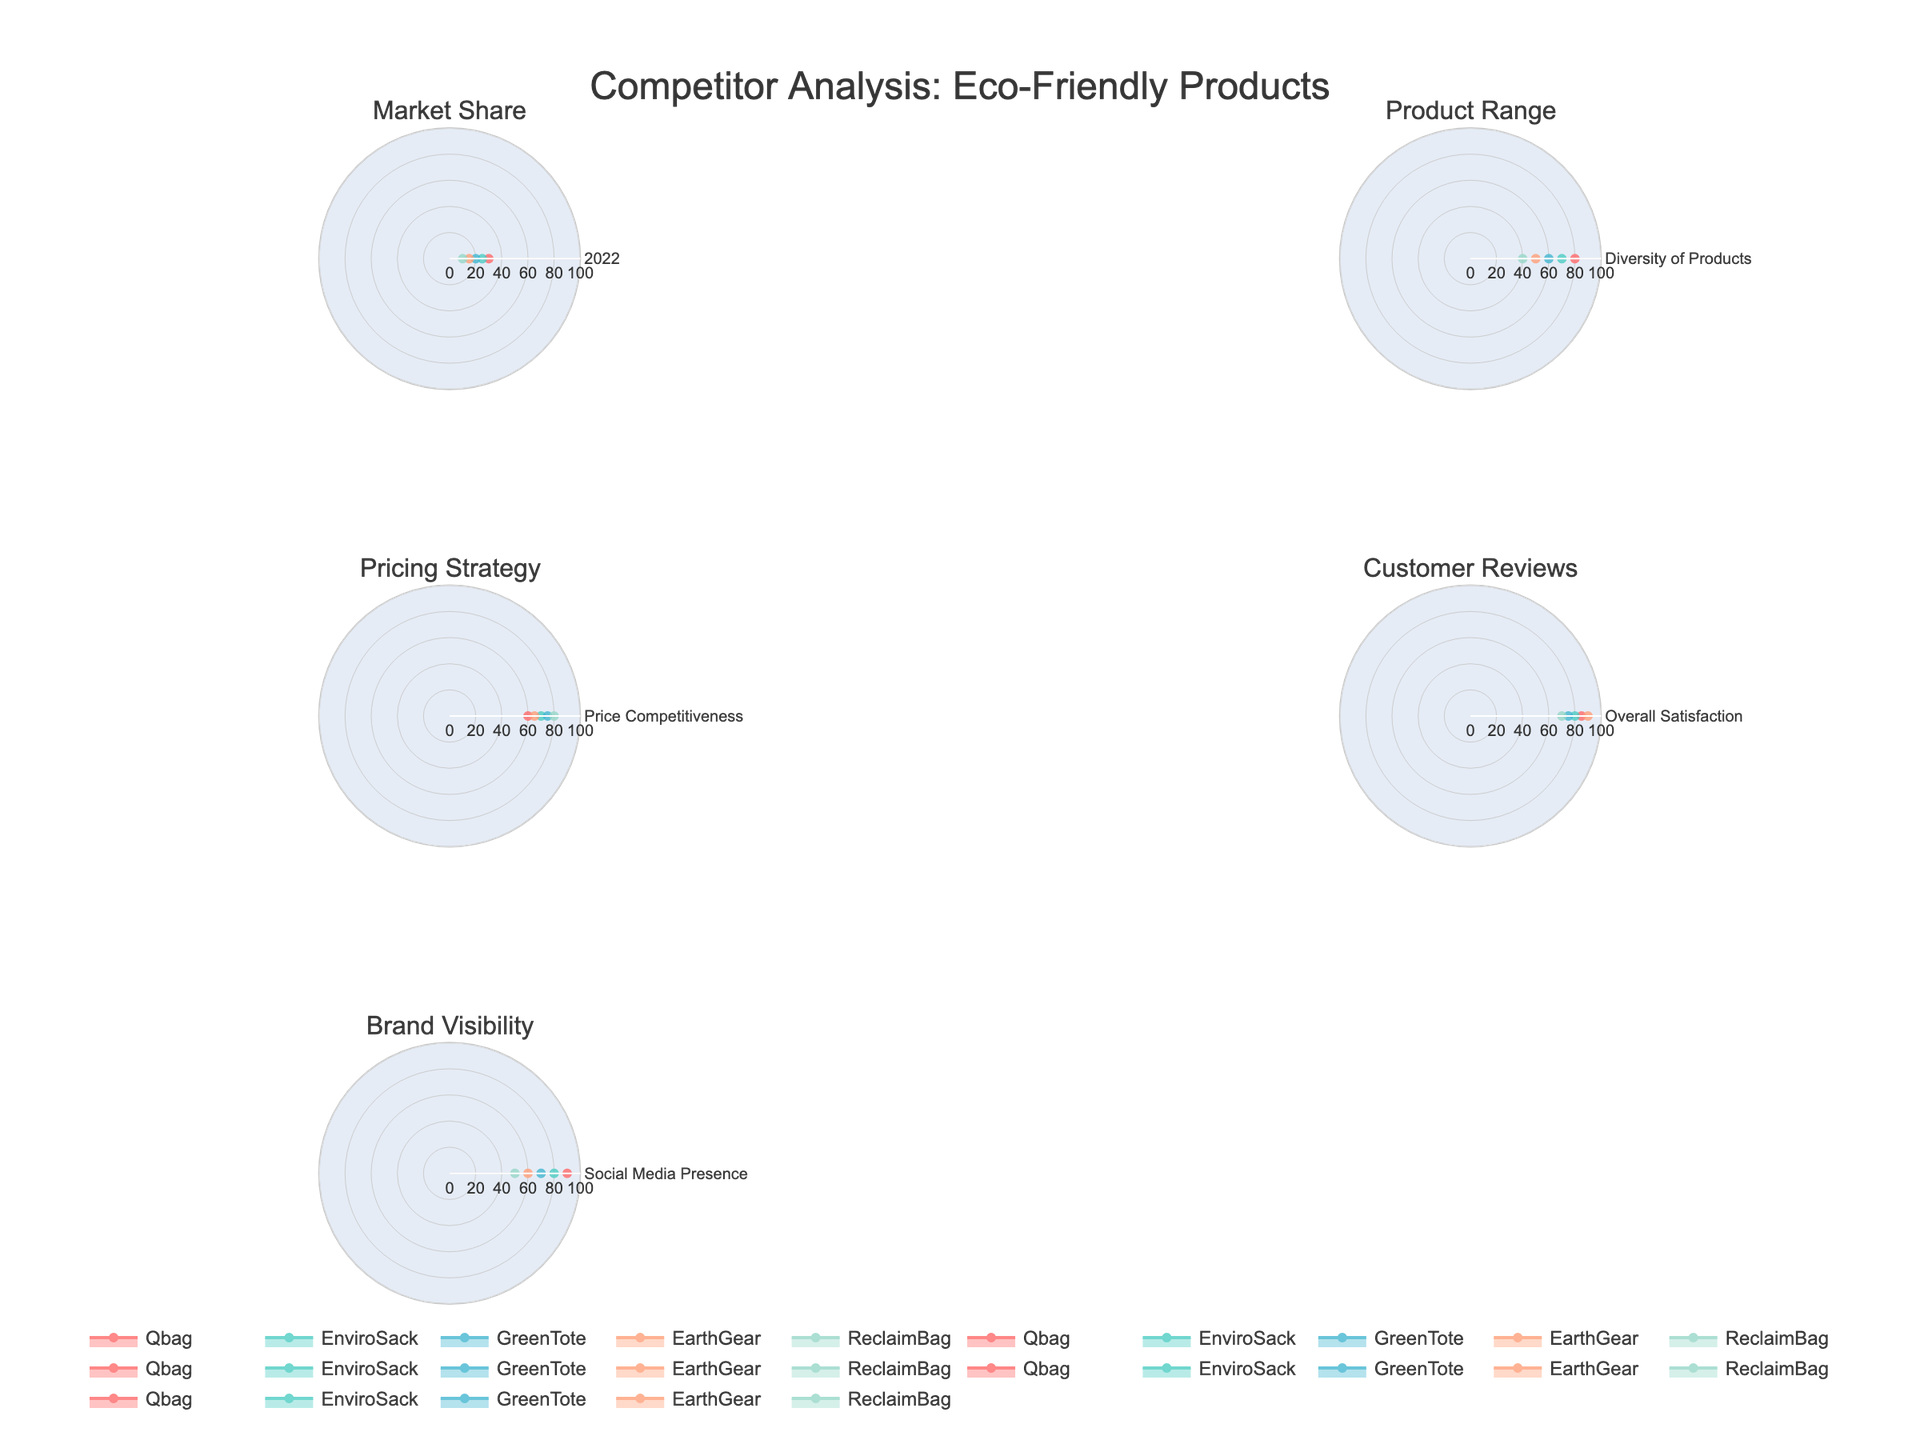Which company has the highest market share? To find the company with the highest market share, look at the "Market Share" subplot. Qbag has the highest score of 30 in this category.
Answer: Qbag What is the diversity of products score for GreenTote? Examine the "Product Range" subplot. GreenTote has a score of 60 for diversity of products.
Answer: 60 Which company has the most competitive pricing strategy? Refer to the "Pricing Strategy" subplot. ReclaimBag has the highest score of 80, indicating the most competitive pricing strategy.
Answer: ReclaimBag How does EnviroSack perform in terms of overall customer satisfaction? Look at the "Customer Reviews" subplot. EnviroSack has a score of 80 in overall satisfaction.
Answer: 80 Which company has the lowest social media presence? The "Brand Visibility" subplot shows that ReclaimBag has the lowest social media presence with a score of 50.
Answer: ReclaimBag Among all companies, which has the highest overall satisfaction? In the "Customer Reviews" subplot, EarthGear has the highest overall satisfaction score of 90.
Answer: EarthGear Compare the diversity of products and the market share for EarthGear. How different are their scores? EarthGear scores 50 in product diversity and 15 in market share. The difference in their scores is 50 - 15 = 35.
Answer: 35 Which company has the best balance between product range and social media presence? To find the best balance, compare scores in "Product Range" and "Brand Visibility". Qbag scores 80 in product range and 90 in social media presence, indicating a strong balance.
Answer: Qbag What is the average market share score among all companies? The market share scores are 30, 25, 20, 15, 10. The average is (30+25+20+15+10)/5 = 20.
Answer: 20 